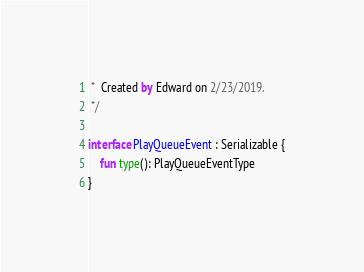<code> <loc_0><loc_0><loc_500><loc_500><_Kotlin_> *  Created by Edward on 2/23/2019.
 */

interface PlayQueueEvent : Serializable {
    fun type(): PlayQueueEventType
}
</code> 